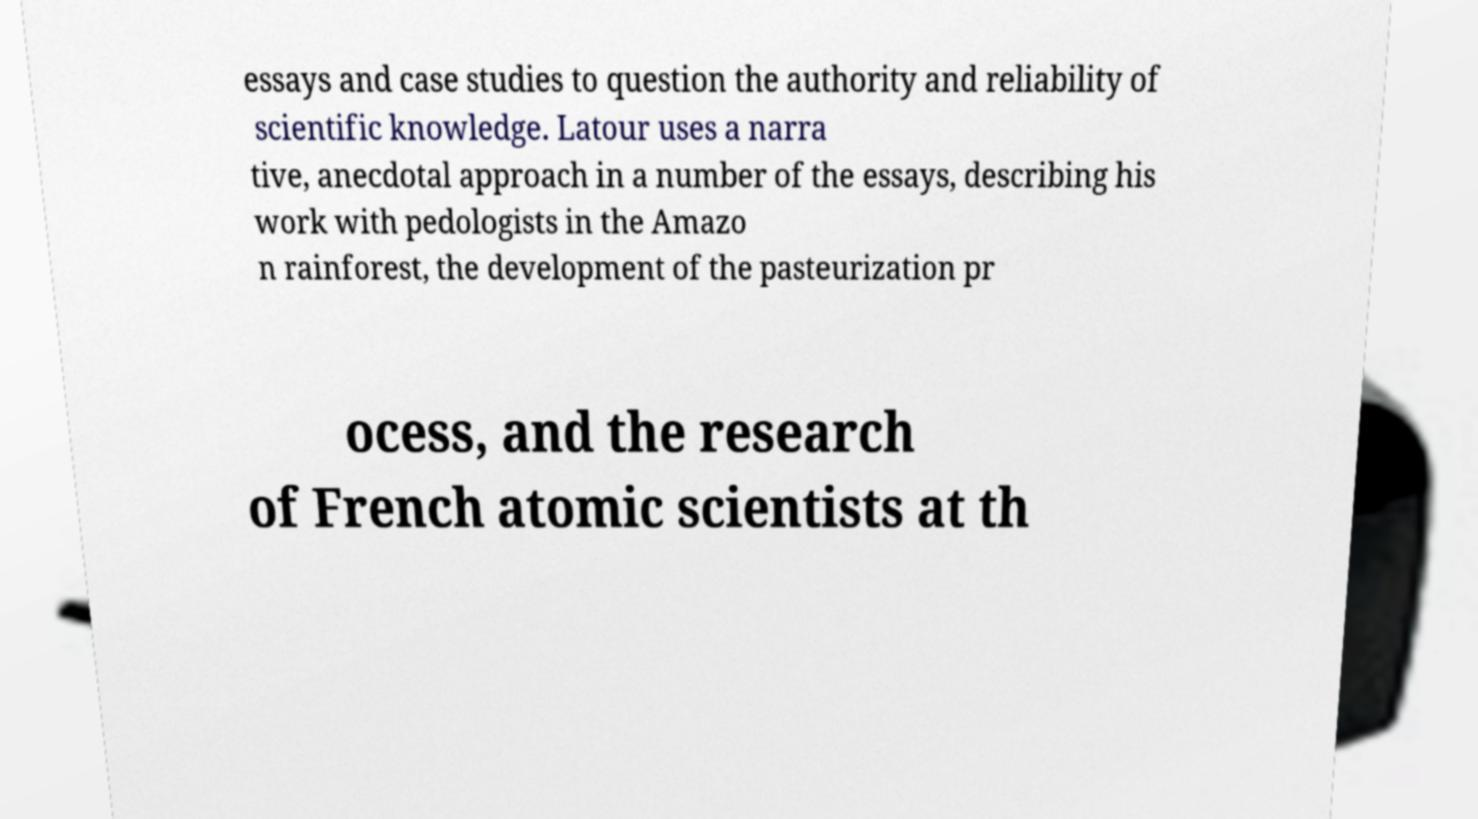For documentation purposes, I need the text within this image transcribed. Could you provide that? essays and case studies to question the authority and reliability of scientific knowledge. Latour uses a narra tive, anecdotal approach in a number of the essays, describing his work with pedologists in the Amazo n rainforest, the development of the pasteurization pr ocess, and the research of French atomic scientists at th 